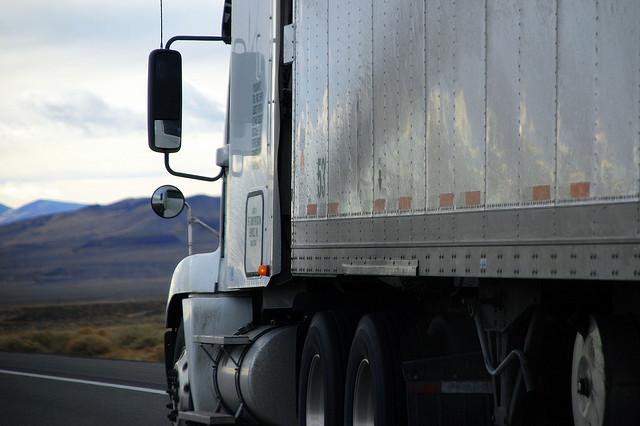Is this a heavy vehicle?
Give a very brief answer. Yes. How many mirrors are visible on the side of the truck?
Answer briefly. 2. What is the truck doing?
Give a very brief answer. Driving. 